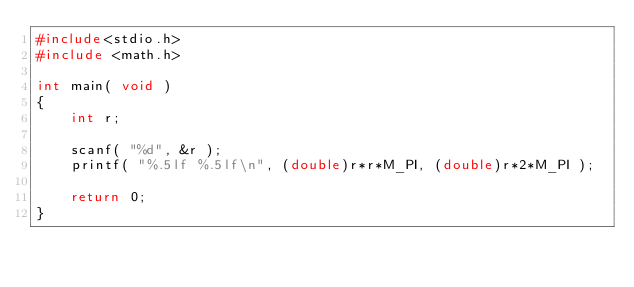Convert code to text. <code><loc_0><loc_0><loc_500><loc_500><_C_>#include<stdio.h>
#include <math.h>

int main( void ) 
{
	int r;
	
	scanf( "%d", &r );	
	printf( "%.5lf %.5lf\n", (double)r*r*M_PI, (double)r*2*M_PI );

	return 0;
}</code> 